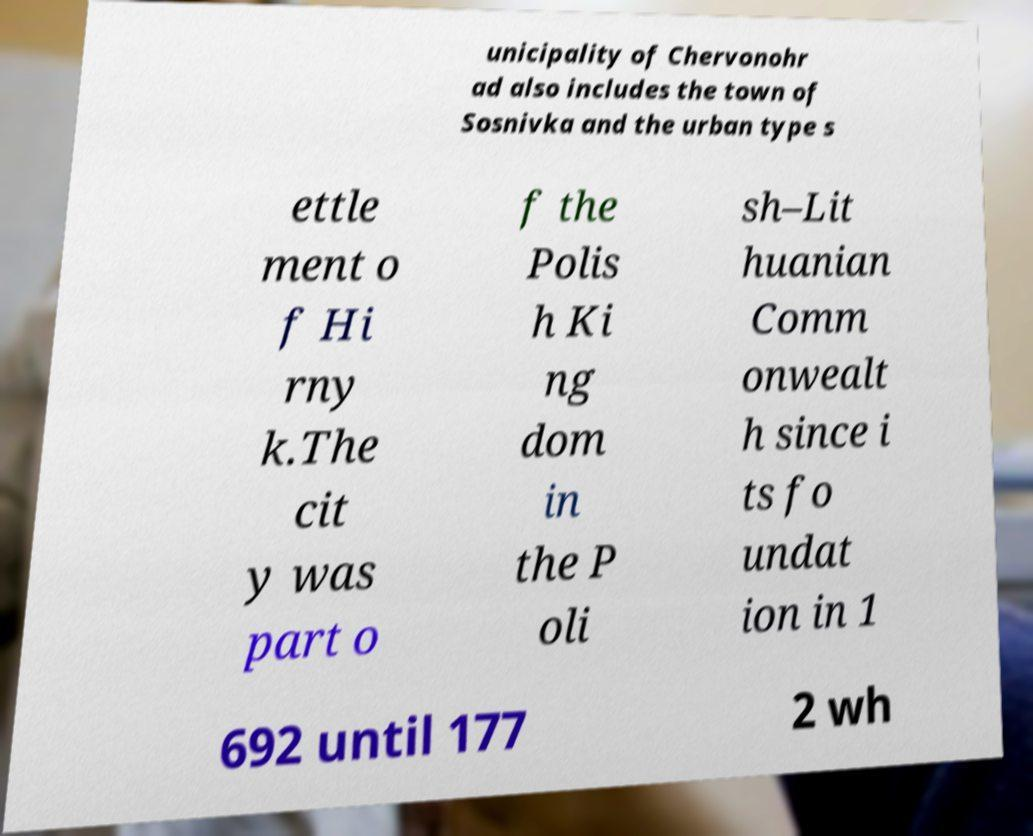Please read and relay the text visible in this image. What does it say? unicipality of Chervonohr ad also includes the town of Sosnivka and the urban type s ettle ment o f Hi rny k.The cit y was part o f the Polis h Ki ng dom in the P oli sh–Lit huanian Comm onwealt h since i ts fo undat ion in 1 692 until 177 2 wh 